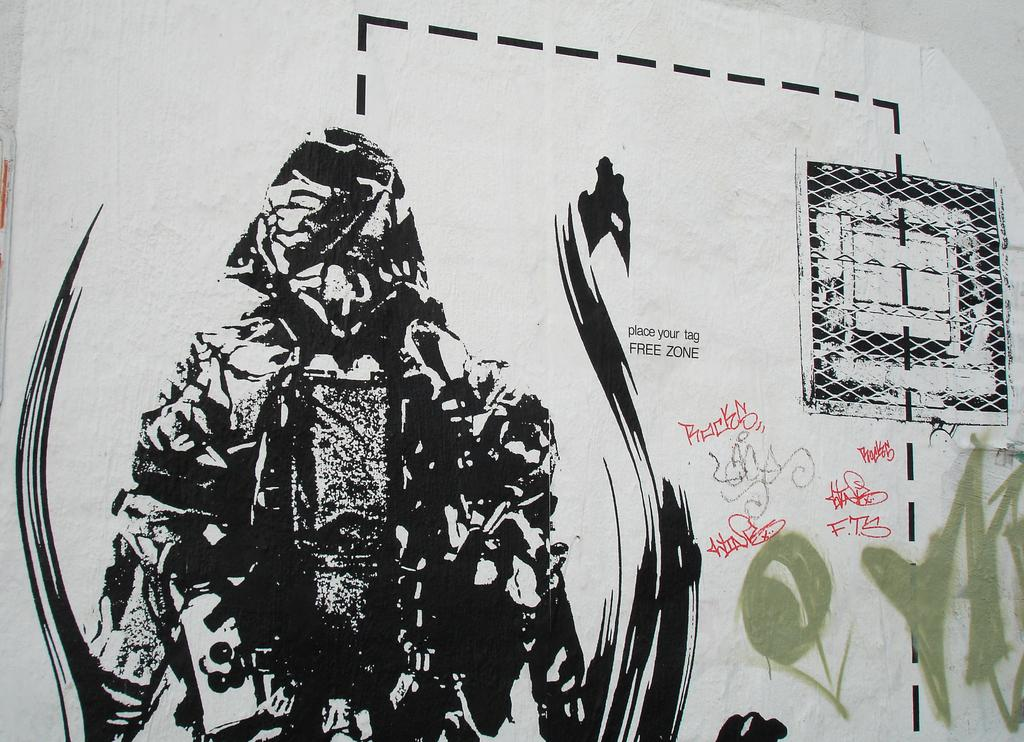What is the main subject of the image? There is an art piece in the image. What color is the art piece? The art piece is in black color. Where is the art piece located? The art piece is painted on a wall. What else can be seen in the image besides the art piece? There is text visible in the image. How many boats are present in the image? There are no boats present in the image; it features an art piece painted on a wall. What type of station is depicted in the art piece? The art piece does not depict a station; it is in black color and painted on a wall. 